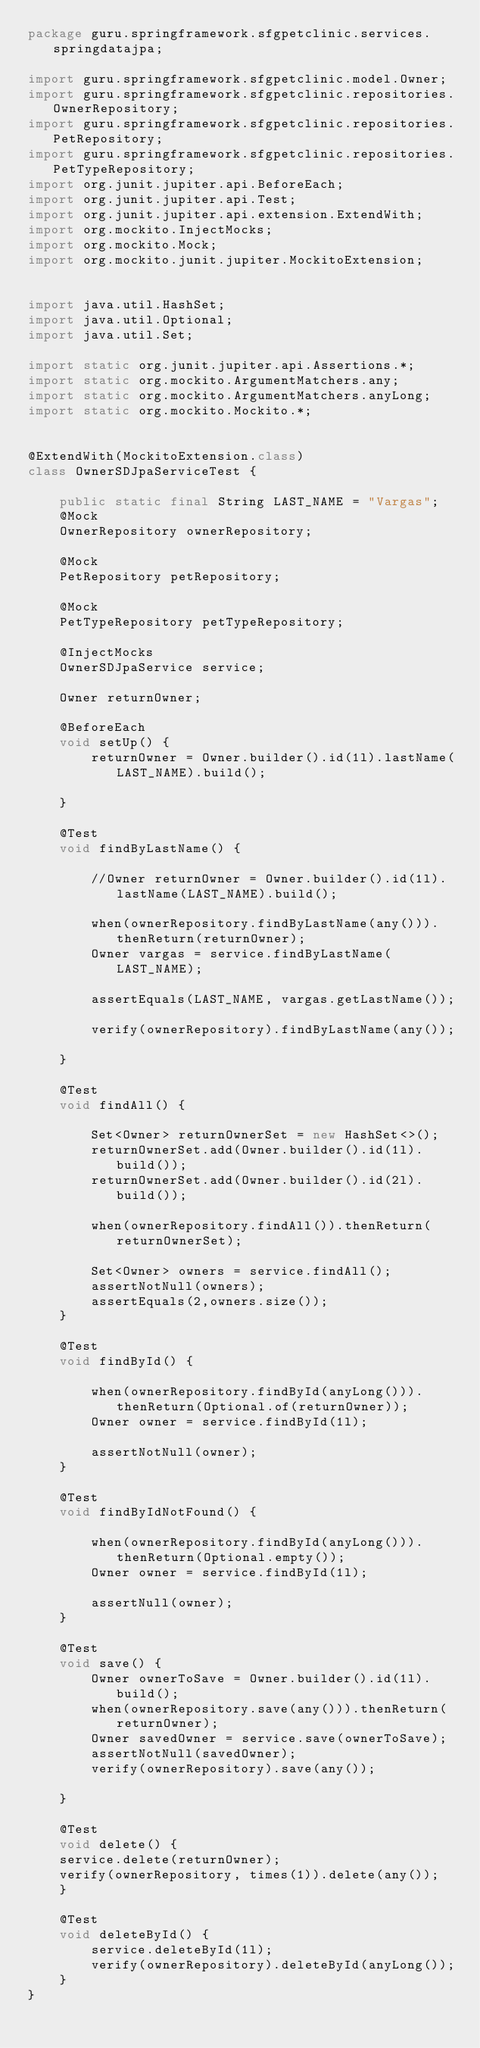<code> <loc_0><loc_0><loc_500><loc_500><_Java_>package guru.springframework.sfgpetclinic.services.springdatajpa;

import guru.springframework.sfgpetclinic.model.Owner;
import guru.springframework.sfgpetclinic.repositories.OwnerRepository;
import guru.springframework.sfgpetclinic.repositories.PetRepository;
import guru.springframework.sfgpetclinic.repositories.PetTypeRepository;
import org.junit.jupiter.api.BeforeEach;
import org.junit.jupiter.api.Test;
import org.junit.jupiter.api.extension.ExtendWith;
import org.mockito.InjectMocks;
import org.mockito.Mock;
import org.mockito.junit.jupiter.MockitoExtension;


import java.util.HashSet;
import java.util.Optional;
import java.util.Set;

import static org.junit.jupiter.api.Assertions.*;
import static org.mockito.ArgumentMatchers.any;
import static org.mockito.ArgumentMatchers.anyLong;
import static org.mockito.Mockito.*;


@ExtendWith(MockitoExtension.class)
class OwnerSDJpaServiceTest {

    public static final String LAST_NAME = "Vargas";
    @Mock
    OwnerRepository ownerRepository;

    @Mock
    PetRepository petRepository;

    @Mock
    PetTypeRepository petTypeRepository;

    @InjectMocks
    OwnerSDJpaService service;

    Owner returnOwner;

    @BeforeEach
    void setUp() {
        returnOwner = Owner.builder().id(1l).lastName(LAST_NAME).build();

    }

    @Test
    void findByLastName() {

        //Owner returnOwner = Owner.builder().id(1l).lastName(LAST_NAME).build();

        when(ownerRepository.findByLastName(any())).thenReturn(returnOwner);
        Owner vargas = service.findByLastName(LAST_NAME);

        assertEquals(LAST_NAME, vargas.getLastName());

        verify(ownerRepository).findByLastName(any());

    }

    @Test
    void findAll() {

        Set<Owner> returnOwnerSet = new HashSet<>();
        returnOwnerSet.add(Owner.builder().id(1l).build());
        returnOwnerSet.add(Owner.builder().id(2l).build());

        when(ownerRepository.findAll()).thenReturn(returnOwnerSet);

        Set<Owner> owners = service.findAll();
        assertNotNull(owners);
        assertEquals(2,owners.size());
    }

    @Test
    void findById() {

        when(ownerRepository.findById(anyLong())).thenReturn(Optional.of(returnOwner));
        Owner owner = service.findById(1l);

        assertNotNull(owner);
    }

    @Test
    void findByIdNotFound() {

        when(ownerRepository.findById(anyLong())).thenReturn(Optional.empty());
        Owner owner = service.findById(1l);

        assertNull(owner);
    }

    @Test
    void save() {
        Owner ownerToSave = Owner.builder().id(1l).build();
        when(ownerRepository.save(any())).thenReturn(returnOwner);
        Owner savedOwner = service.save(ownerToSave);
        assertNotNull(savedOwner);
        verify(ownerRepository).save(any());

    }

    @Test
    void delete() {
    service.delete(returnOwner);
    verify(ownerRepository, times(1)).delete(any());
    }

    @Test
    void deleteById() {
        service.deleteById(1l);
        verify(ownerRepository).deleteById(anyLong());
    }
}</code> 